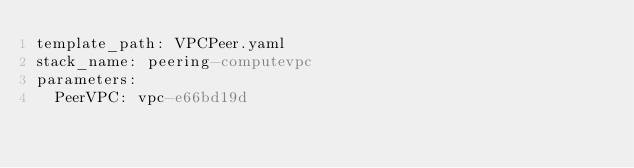Convert code to text. <code><loc_0><loc_0><loc_500><loc_500><_YAML_>template_path: VPCPeer.yaml
stack_name: peering-computevpc
parameters:
  PeerVPC: vpc-e66bd19d</code> 